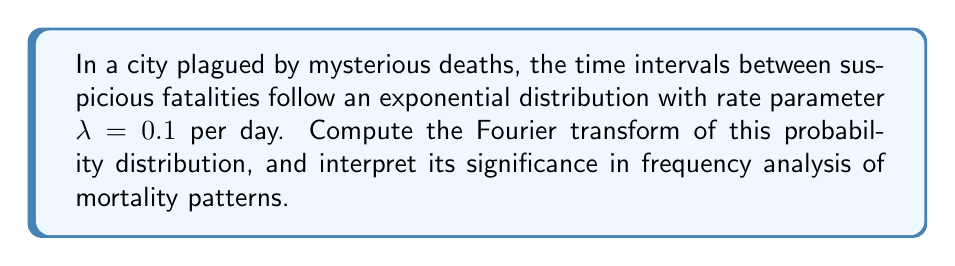Can you solve this math problem? Let's approach this step-by-step:

1) The probability density function (PDF) of an exponential distribution with rate parameter $\lambda$ is given by:

   $$f(t) = \lambda e^{-\lambda t}, \quad t \geq 0$$

2) The Fourier transform of a function $f(t)$ is defined as:

   $$F(\omega) = \int_{-\infty}^{\infty} f(t) e^{-i\omega t} dt$$

3) For our exponential distribution, we need to compute:

   $$F(\omega) = \int_{0}^{\infty} \lambda e^{-\lambda t} e^{-i\omega t} dt$$

4) Combining the exponents:

   $$F(\omega) = \lambda \int_{0}^{\infty} e^{-(\lambda + i\omega)t} dt$$

5) This integral can be solved using the formula $\int_{0}^{\infty} e^{-at} dt = \frac{1}{a}$ for $Re(a) > 0$:

   $$F(\omega) = \lambda \cdot \frac{1}{\lambda + i\omega} = \frac{\lambda}{\lambda + i\omega}$$

6) Simplifying:

   $$F(\omega) = \frac{\lambda}{\lambda + i\omega} = \frac{\lambda(\lambda - i\omega)}{(\lambda + i\omega)(\lambda - i\omega)} = \frac{\lambda^2 - i\lambda\omega}{\lambda^2 + \omega^2}$$

7) Interpretation: The Fourier transform represents the distribution in the frequency domain. The magnitude of $F(\omega)$ decays as $\omega$ increases, indicating that high-frequency components (rapid fluctuations in death intervals) are less prominent. The phase of $F(\omega)$ represents the time delay in the frequency components.
Answer: $$F(\omega) = \frac{\lambda}{\lambda + i\omega} = \frac{0.1}{0.1 + i\omega}$$ 